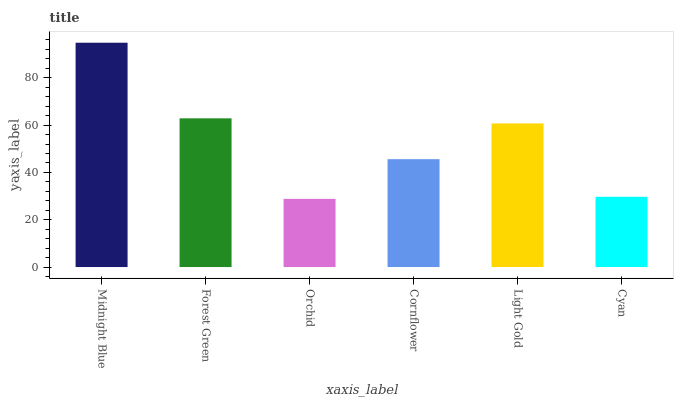Is Orchid the minimum?
Answer yes or no. Yes. Is Midnight Blue the maximum?
Answer yes or no. Yes. Is Forest Green the minimum?
Answer yes or no. No. Is Forest Green the maximum?
Answer yes or no. No. Is Midnight Blue greater than Forest Green?
Answer yes or no. Yes. Is Forest Green less than Midnight Blue?
Answer yes or no. Yes. Is Forest Green greater than Midnight Blue?
Answer yes or no. No. Is Midnight Blue less than Forest Green?
Answer yes or no. No. Is Light Gold the high median?
Answer yes or no. Yes. Is Cornflower the low median?
Answer yes or no. Yes. Is Forest Green the high median?
Answer yes or no. No. Is Cyan the low median?
Answer yes or no. No. 